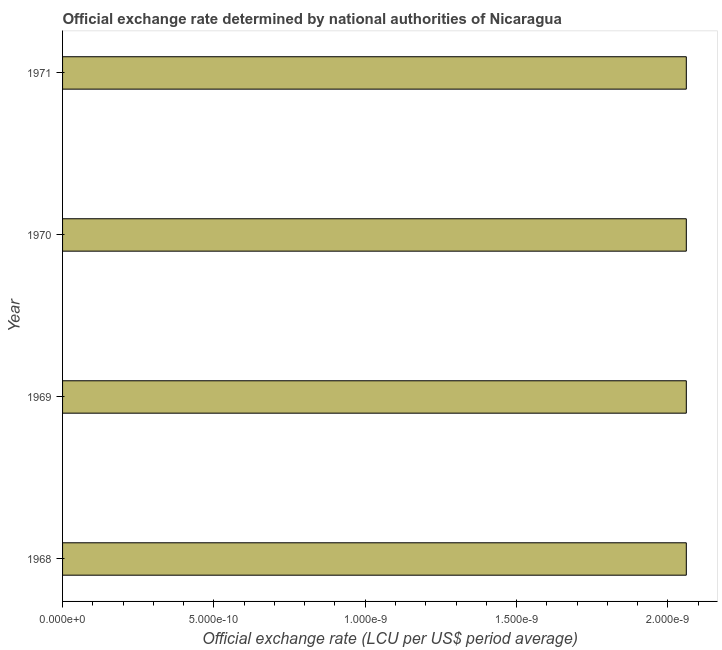Does the graph contain any zero values?
Your answer should be compact. No. What is the title of the graph?
Ensure brevity in your answer.  Official exchange rate determined by national authorities of Nicaragua. What is the label or title of the X-axis?
Offer a very short reply. Official exchange rate (LCU per US$ period average). What is the official exchange rate in 1971?
Keep it short and to the point. 2.060644189655169e-9. Across all years, what is the maximum official exchange rate?
Provide a short and direct response. 2.060644189655169e-9. Across all years, what is the minimum official exchange rate?
Your answer should be compact. 2.060644189655169e-9. In which year was the official exchange rate maximum?
Ensure brevity in your answer.  1968. In which year was the official exchange rate minimum?
Ensure brevity in your answer.  1968. What is the sum of the official exchange rate?
Give a very brief answer. 8.242576758620676e-9. What is the median official exchange rate?
Offer a very short reply. 2.060644189655169e-9. Do a majority of the years between 1969 and 1971 (inclusive) have official exchange rate greater than 1.1e-09 ?
Your answer should be compact. Yes. What is the ratio of the official exchange rate in 1970 to that in 1971?
Make the answer very short. 1. Is the difference between the official exchange rate in 1969 and 1970 greater than the difference between any two years?
Offer a very short reply. Yes. Is the sum of the official exchange rate in 1969 and 1970 greater than the maximum official exchange rate across all years?
Make the answer very short. Yes. What is the difference between the highest and the lowest official exchange rate?
Provide a short and direct response. 0. How many bars are there?
Offer a very short reply. 4. What is the difference between two consecutive major ticks on the X-axis?
Keep it short and to the point. 5e-10. What is the Official exchange rate (LCU per US$ period average) of 1968?
Give a very brief answer. 2.060644189655169e-9. What is the Official exchange rate (LCU per US$ period average) of 1969?
Give a very brief answer. 2.060644189655169e-9. What is the Official exchange rate (LCU per US$ period average) of 1970?
Provide a short and direct response. 2.060644189655169e-9. What is the Official exchange rate (LCU per US$ period average) of 1971?
Provide a succinct answer. 2.060644189655169e-9. What is the difference between the Official exchange rate (LCU per US$ period average) in 1968 and 1969?
Give a very brief answer. 0. What is the difference between the Official exchange rate (LCU per US$ period average) in 1968 and 1970?
Your response must be concise. 0. What is the difference between the Official exchange rate (LCU per US$ period average) in 1969 and 1970?
Make the answer very short. 0. What is the difference between the Official exchange rate (LCU per US$ period average) in 1970 and 1971?
Offer a very short reply. 0. What is the ratio of the Official exchange rate (LCU per US$ period average) in 1968 to that in 1969?
Ensure brevity in your answer.  1. What is the ratio of the Official exchange rate (LCU per US$ period average) in 1968 to that in 1971?
Your answer should be compact. 1. What is the ratio of the Official exchange rate (LCU per US$ period average) in 1969 to that in 1970?
Ensure brevity in your answer.  1. What is the ratio of the Official exchange rate (LCU per US$ period average) in 1969 to that in 1971?
Provide a succinct answer. 1. What is the ratio of the Official exchange rate (LCU per US$ period average) in 1970 to that in 1971?
Make the answer very short. 1. 